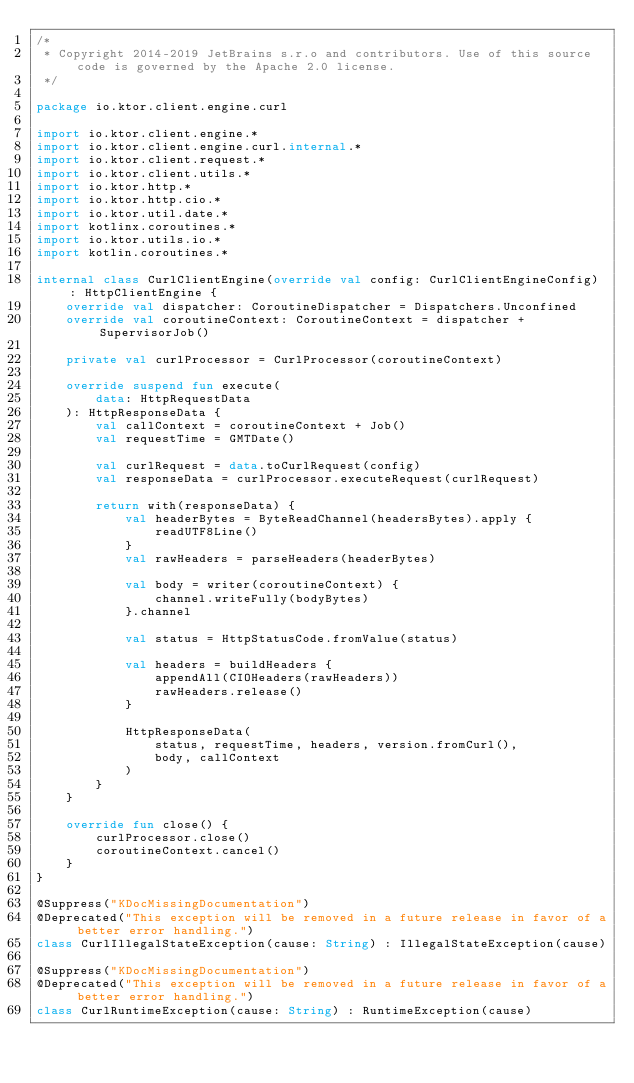Convert code to text. <code><loc_0><loc_0><loc_500><loc_500><_Kotlin_>/*
 * Copyright 2014-2019 JetBrains s.r.o and contributors. Use of this source code is governed by the Apache 2.0 license.
 */

package io.ktor.client.engine.curl

import io.ktor.client.engine.*
import io.ktor.client.engine.curl.internal.*
import io.ktor.client.request.*
import io.ktor.client.utils.*
import io.ktor.http.*
import io.ktor.http.cio.*
import io.ktor.util.date.*
import kotlinx.coroutines.*
import io.ktor.utils.io.*
import kotlin.coroutines.*

internal class CurlClientEngine(override val config: CurlClientEngineConfig) : HttpClientEngine {
    override val dispatcher: CoroutineDispatcher = Dispatchers.Unconfined
    override val coroutineContext: CoroutineContext = dispatcher + SupervisorJob()

    private val curlProcessor = CurlProcessor(coroutineContext)

    override suspend fun execute(
        data: HttpRequestData
    ): HttpResponseData {
        val callContext = coroutineContext + Job()
        val requestTime = GMTDate()

        val curlRequest = data.toCurlRequest(config)
        val responseData = curlProcessor.executeRequest(curlRequest)

        return with(responseData) {
            val headerBytes = ByteReadChannel(headersBytes).apply {
                readUTF8Line()
            }
            val rawHeaders = parseHeaders(headerBytes)

            val body = writer(coroutineContext) {
                channel.writeFully(bodyBytes)
            }.channel

            val status = HttpStatusCode.fromValue(status)

            val headers = buildHeaders {
                appendAll(CIOHeaders(rawHeaders))
                rawHeaders.release()
            }

            HttpResponseData(
                status, requestTime, headers, version.fromCurl(),
                body, callContext
            )
        }
    }

    override fun close() {
        curlProcessor.close()
        coroutineContext.cancel()
    }
}

@Suppress("KDocMissingDocumentation")
@Deprecated("This exception will be removed in a future release in favor of a better error handling.")
class CurlIllegalStateException(cause: String) : IllegalStateException(cause)

@Suppress("KDocMissingDocumentation")
@Deprecated("This exception will be removed in a future release in favor of a better error handling.")
class CurlRuntimeException(cause: String) : RuntimeException(cause)
</code> 